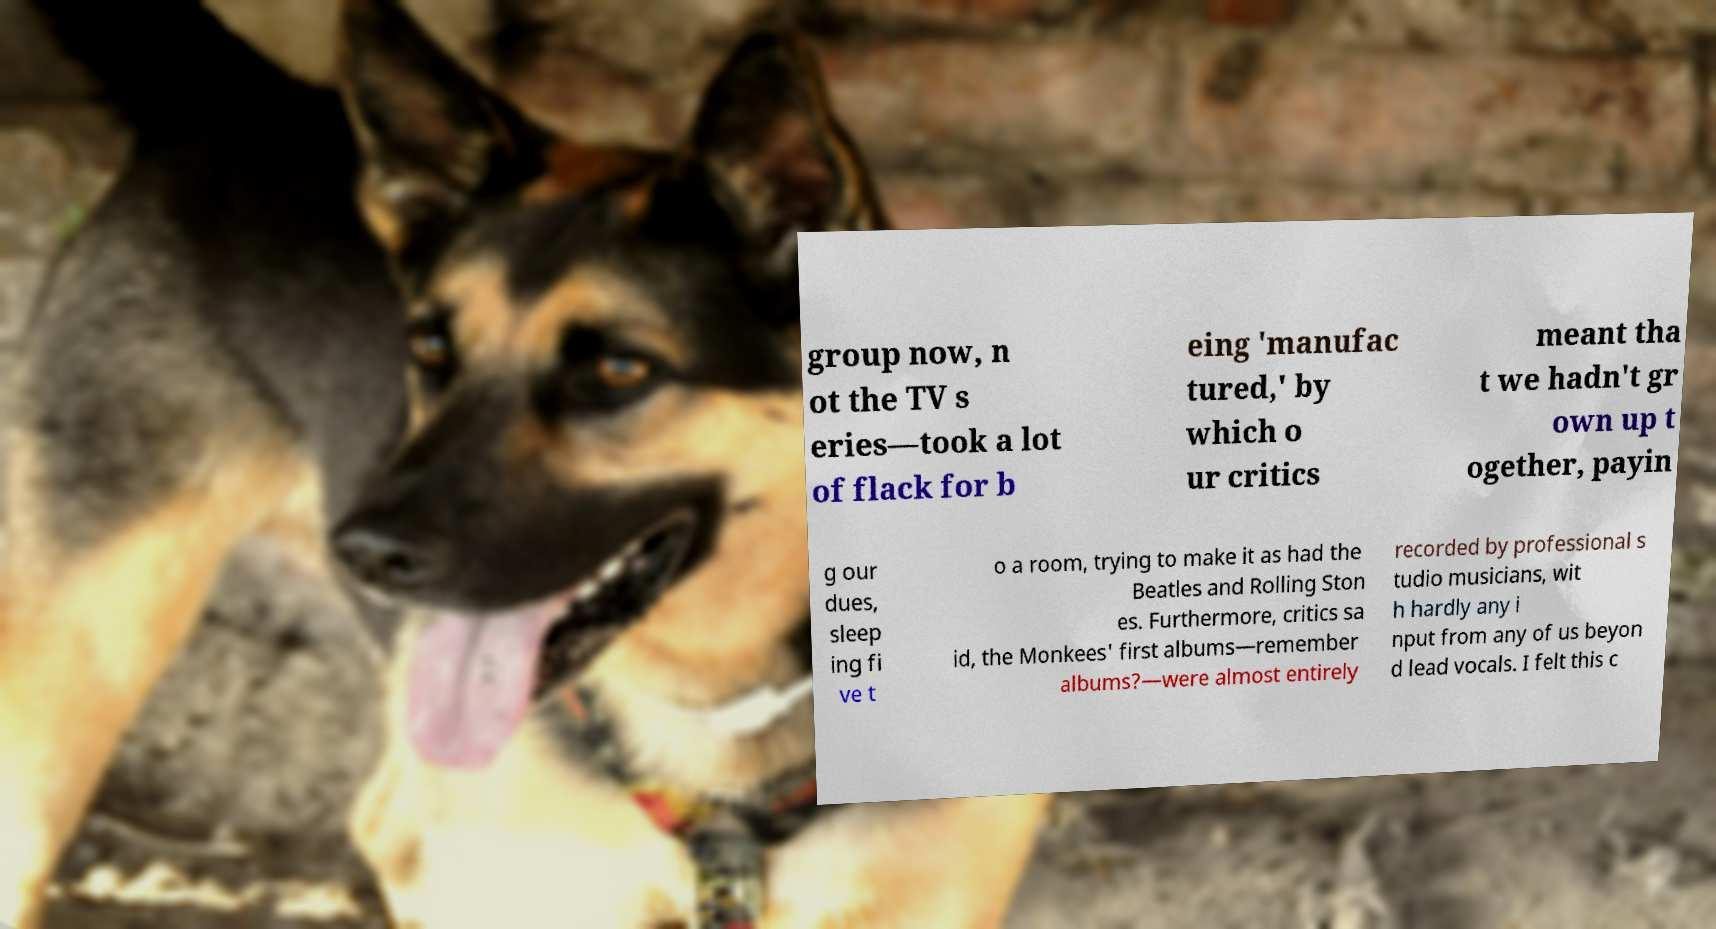Could you assist in decoding the text presented in this image and type it out clearly? group now, n ot the TV s eries—took a lot of flack for b eing 'manufac tured,' by which o ur critics meant tha t we hadn't gr own up t ogether, payin g our dues, sleep ing fi ve t o a room, trying to make it as had the Beatles and Rolling Ston es. Furthermore, critics sa id, the Monkees' first albums—remember albums?—were almost entirely recorded by professional s tudio musicians, wit h hardly any i nput from any of us beyon d lead vocals. I felt this c 